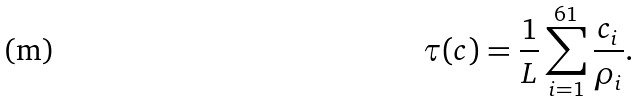Convert formula to latex. <formula><loc_0><loc_0><loc_500><loc_500>\tau ( { c } { ) } = \frac { 1 } { L } \sum _ { i = 1 } ^ { 6 1 } \frac { c _ { i } } { \rho _ { i } } .</formula> 